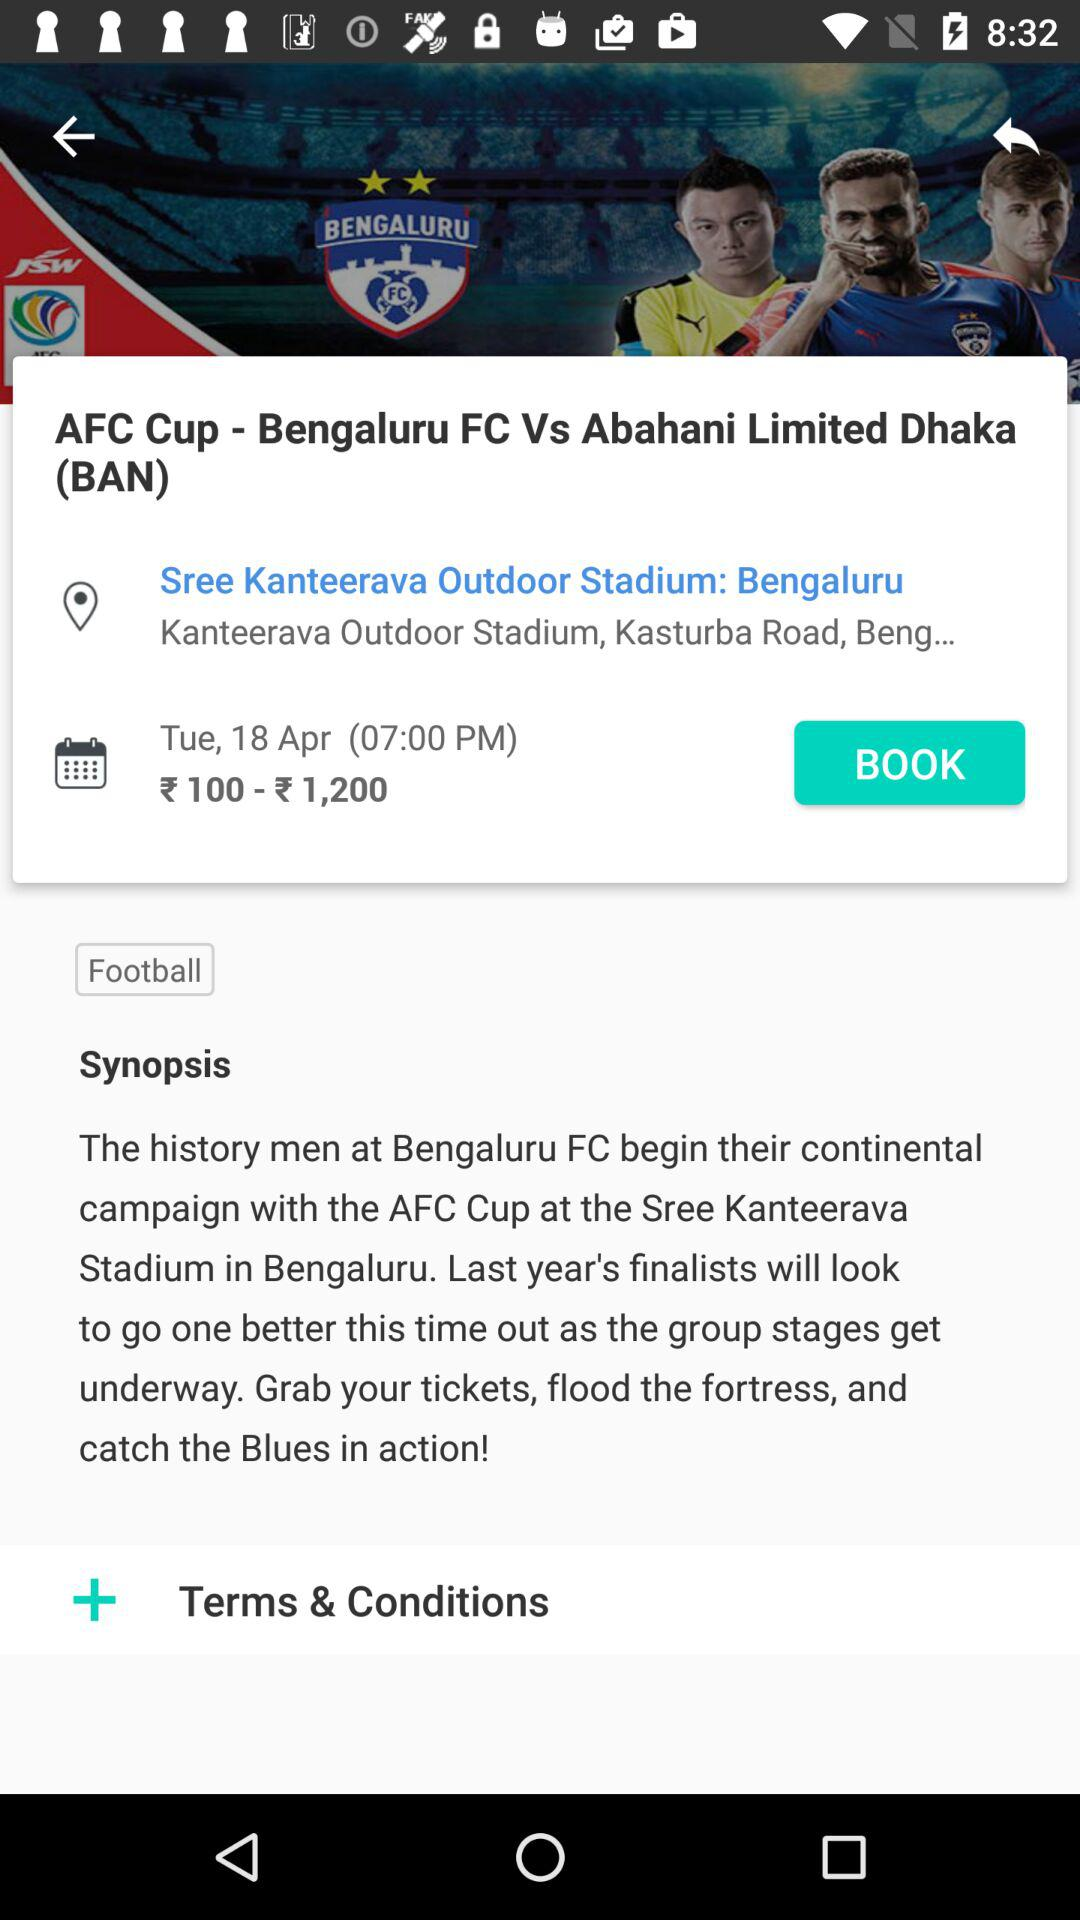What teams are playing for the AFC Cup? The teams playing for the AFC Cup are "Bengaluru FC" and "Abahani Limited Dhaka (BAN)". 